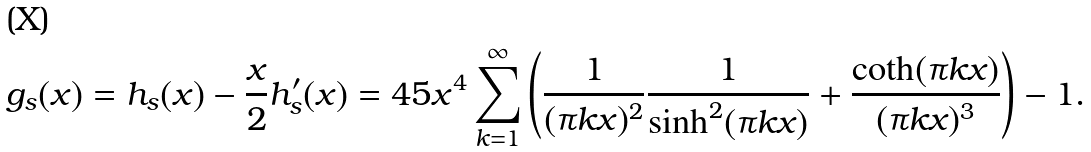<formula> <loc_0><loc_0><loc_500><loc_500>g _ { s } ( x ) = h _ { s } ( x ) - \frac { x } { 2 } h _ { s } ^ { \prime } ( x ) = 4 5 x ^ { 4 } \sum _ { k = 1 } ^ { \infty } \left ( \frac { 1 } { ( \pi k x ) ^ { 2 } } \frac { 1 } { \sinh ^ { 2 } ( \pi k x ) } + \frac { \coth ( \pi k x ) } { ( \pi k x ) ^ { 3 } } \right ) - 1 .</formula> 